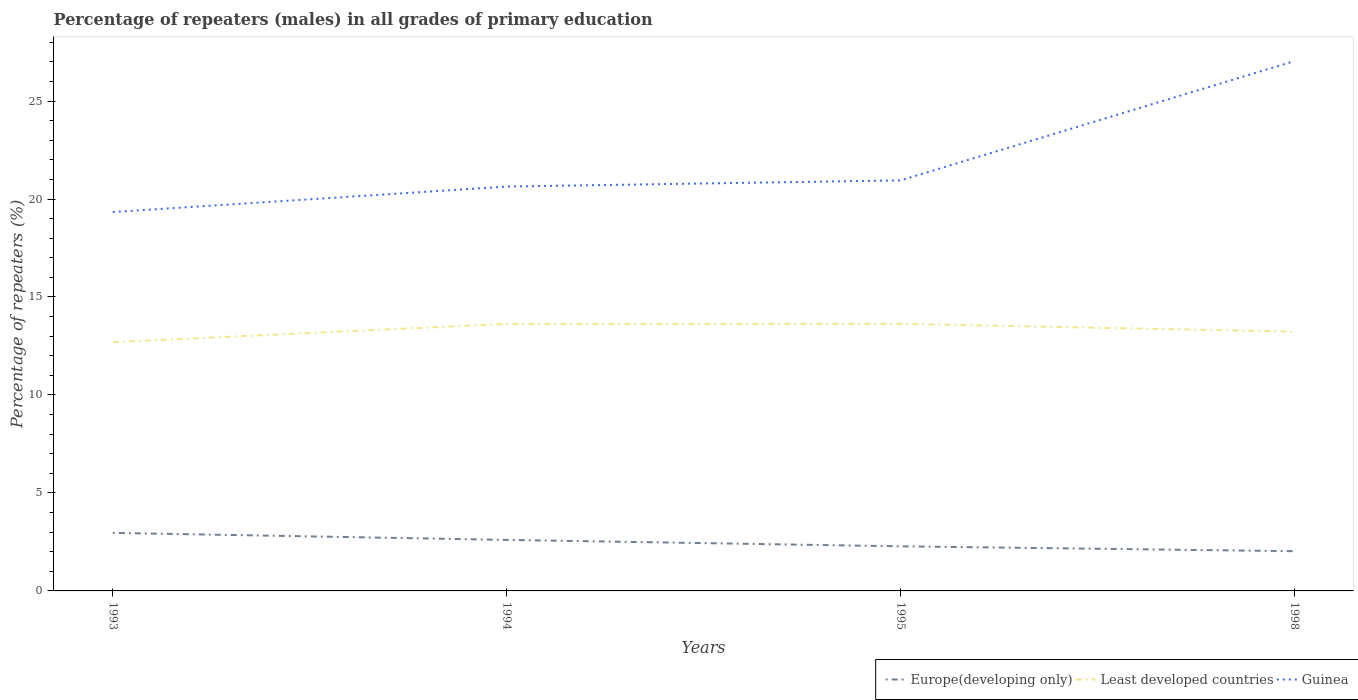How many different coloured lines are there?
Offer a very short reply. 3. Does the line corresponding to Europe(developing only) intersect with the line corresponding to Least developed countries?
Make the answer very short. No. Across all years, what is the maximum percentage of repeaters (males) in Least developed countries?
Ensure brevity in your answer.  12.7. What is the total percentage of repeaters (males) in Guinea in the graph?
Ensure brevity in your answer.  -1.3. What is the difference between the highest and the second highest percentage of repeaters (males) in Europe(developing only)?
Your answer should be compact. 0.94. What is the difference between two consecutive major ticks on the Y-axis?
Your answer should be compact. 5. Are the values on the major ticks of Y-axis written in scientific E-notation?
Your response must be concise. No. Where does the legend appear in the graph?
Provide a succinct answer. Bottom right. How are the legend labels stacked?
Give a very brief answer. Horizontal. What is the title of the graph?
Ensure brevity in your answer.  Percentage of repeaters (males) in all grades of primary education. Does "Seychelles" appear as one of the legend labels in the graph?
Offer a very short reply. No. What is the label or title of the X-axis?
Give a very brief answer. Years. What is the label or title of the Y-axis?
Keep it short and to the point. Percentage of repeaters (%). What is the Percentage of repeaters (%) in Europe(developing only) in 1993?
Offer a terse response. 2.96. What is the Percentage of repeaters (%) of Least developed countries in 1993?
Your answer should be compact. 12.7. What is the Percentage of repeaters (%) in Guinea in 1993?
Offer a terse response. 19.34. What is the Percentage of repeaters (%) of Europe(developing only) in 1994?
Make the answer very short. 2.6. What is the Percentage of repeaters (%) of Least developed countries in 1994?
Keep it short and to the point. 13.63. What is the Percentage of repeaters (%) in Guinea in 1994?
Offer a very short reply. 20.64. What is the Percentage of repeaters (%) in Europe(developing only) in 1995?
Offer a terse response. 2.28. What is the Percentage of repeaters (%) in Least developed countries in 1995?
Give a very brief answer. 13.63. What is the Percentage of repeaters (%) in Guinea in 1995?
Ensure brevity in your answer.  20.95. What is the Percentage of repeaters (%) in Europe(developing only) in 1998?
Your answer should be very brief. 2.03. What is the Percentage of repeaters (%) of Least developed countries in 1998?
Provide a succinct answer. 13.23. What is the Percentage of repeaters (%) in Guinea in 1998?
Your response must be concise. 27.04. Across all years, what is the maximum Percentage of repeaters (%) of Europe(developing only)?
Offer a very short reply. 2.96. Across all years, what is the maximum Percentage of repeaters (%) in Least developed countries?
Make the answer very short. 13.63. Across all years, what is the maximum Percentage of repeaters (%) in Guinea?
Make the answer very short. 27.04. Across all years, what is the minimum Percentage of repeaters (%) of Europe(developing only)?
Your response must be concise. 2.03. Across all years, what is the minimum Percentage of repeaters (%) in Least developed countries?
Your response must be concise. 12.7. Across all years, what is the minimum Percentage of repeaters (%) in Guinea?
Make the answer very short. 19.34. What is the total Percentage of repeaters (%) of Europe(developing only) in the graph?
Keep it short and to the point. 9.87. What is the total Percentage of repeaters (%) of Least developed countries in the graph?
Provide a short and direct response. 53.19. What is the total Percentage of repeaters (%) of Guinea in the graph?
Your answer should be compact. 87.96. What is the difference between the Percentage of repeaters (%) of Europe(developing only) in 1993 and that in 1994?
Your response must be concise. 0.36. What is the difference between the Percentage of repeaters (%) of Least developed countries in 1993 and that in 1994?
Give a very brief answer. -0.93. What is the difference between the Percentage of repeaters (%) of Guinea in 1993 and that in 1994?
Give a very brief answer. -1.3. What is the difference between the Percentage of repeaters (%) in Europe(developing only) in 1993 and that in 1995?
Give a very brief answer. 0.69. What is the difference between the Percentage of repeaters (%) in Least developed countries in 1993 and that in 1995?
Your answer should be compact. -0.93. What is the difference between the Percentage of repeaters (%) of Guinea in 1993 and that in 1995?
Give a very brief answer. -1.61. What is the difference between the Percentage of repeaters (%) in Europe(developing only) in 1993 and that in 1998?
Give a very brief answer. 0.94. What is the difference between the Percentage of repeaters (%) in Least developed countries in 1993 and that in 1998?
Provide a succinct answer. -0.54. What is the difference between the Percentage of repeaters (%) in Guinea in 1993 and that in 1998?
Keep it short and to the point. -7.7. What is the difference between the Percentage of repeaters (%) of Europe(developing only) in 1994 and that in 1995?
Your response must be concise. 0.33. What is the difference between the Percentage of repeaters (%) of Least developed countries in 1994 and that in 1995?
Provide a succinct answer. -0. What is the difference between the Percentage of repeaters (%) in Guinea in 1994 and that in 1995?
Offer a terse response. -0.31. What is the difference between the Percentage of repeaters (%) of Europe(developing only) in 1994 and that in 1998?
Your answer should be very brief. 0.58. What is the difference between the Percentage of repeaters (%) in Least developed countries in 1994 and that in 1998?
Give a very brief answer. 0.4. What is the difference between the Percentage of repeaters (%) of Guinea in 1994 and that in 1998?
Give a very brief answer. -6.4. What is the difference between the Percentage of repeaters (%) in Europe(developing only) in 1995 and that in 1998?
Keep it short and to the point. 0.25. What is the difference between the Percentage of repeaters (%) of Least developed countries in 1995 and that in 1998?
Your answer should be very brief. 0.4. What is the difference between the Percentage of repeaters (%) in Guinea in 1995 and that in 1998?
Make the answer very short. -6.09. What is the difference between the Percentage of repeaters (%) in Europe(developing only) in 1993 and the Percentage of repeaters (%) in Least developed countries in 1994?
Your response must be concise. -10.67. What is the difference between the Percentage of repeaters (%) of Europe(developing only) in 1993 and the Percentage of repeaters (%) of Guinea in 1994?
Offer a very short reply. -17.67. What is the difference between the Percentage of repeaters (%) of Least developed countries in 1993 and the Percentage of repeaters (%) of Guinea in 1994?
Your answer should be very brief. -7.94. What is the difference between the Percentage of repeaters (%) of Europe(developing only) in 1993 and the Percentage of repeaters (%) of Least developed countries in 1995?
Your response must be concise. -10.67. What is the difference between the Percentage of repeaters (%) in Europe(developing only) in 1993 and the Percentage of repeaters (%) in Guinea in 1995?
Offer a terse response. -17.99. What is the difference between the Percentage of repeaters (%) in Least developed countries in 1993 and the Percentage of repeaters (%) in Guinea in 1995?
Provide a short and direct response. -8.25. What is the difference between the Percentage of repeaters (%) of Europe(developing only) in 1993 and the Percentage of repeaters (%) of Least developed countries in 1998?
Your response must be concise. -10.27. What is the difference between the Percentage of repeaters (%) in Europe(developing only) in 1993 and the Percentage of repeaters (%) in Guinea in 1998?
Provide a short and direct response. -24.08. What is the difference between the Percentage of repeaters (%) in Least developed countries in 1993 and the Percentage of repeaters (%) in Guinea in 1998?
Your answer should be compact. -14.34. What is the difference between the Percentage of repeaters (%) in Europe(developing only) in 1994 and the Percentage of repeaters (%) in Least developed countries in 1995?
Your response must be concise. -11.03. What is the difference between the Percentage of repeaters (%) in Europe(developing only) in 1994 and the Percentage of repeaters (%) in Guinea in 1995?
Keep it short and to the point. -18.35. What is the difference between the Percentage of repeaters (%) of Least developed countries in 1994 and the Percentage of repeaters (%) of Guinea in 1995?
Make the answer very short. -7.32. What is the difference between the Percentage of repeaters (%) of Europe(developing only) in 1994 and the Percentage of repeaters (%) of Least developed countries in 1998?
Your answer should be compact. -10.63. What is the difference between the Percentage of repeaters (%) in Europe(developing only) in 1994 and the Percentage of repeaters (%) in Guinea in 1998?
Offer a very short reply. -24.44. What is the difference between the Percentage of repeaters (%) of Least developed countries in 1994 and the Percentage of repeaters (%) of Guinea in 1998?
Offer a terse response. -13.41. What is the difference between the Percentage of repeaters (%) of Europe(developing only) in 1995 and the Percentage of repeaters (%) of Least developed countries in 1998?
Make the answer very short. -10.96. What is the difference between the Percentage of repeaters (%) in Europe(developing only) in 1995 and the Percentage of repeaters (%) in Guinea in 1998?
Offer a very short reply. -24.76. What is the difference between the Percentage of repeaters (%) in Least developed countries in 1995 and the Percentage of repeaters (%) in Guinea in 1998?
Your answer should be very brief. -13.41. What is the average Percentage of repeaters (%) in Europe(developing only) per year?
Keep it short and to the point. 2.47. What is the average Percentage of repeaters (%) of Least developed countries per year?
Provide a short and direct response. 13.3. What is the average Percentage of repeaters (%) in Guinea per year?
Your response must be concise. 21.99. In the year 1993, what is the difference between the Percentage of repeaters (%) in Europe(developing only) and Percentage of repeaters (%) in Least developed countries?
Keep it short and to the point. -9.73. In the year 1993, what is the difference between the Percentage of repeaters (%) in Europe(developing only) and Percentage of repeaters (%) in Guinea?
Ensure brevity in your answer.  -16.37. In the year 1993, what is the difference between the Percentage of repeaters (%) in Least developed countries and Percentage of repeaters (%) in Guinea?
Offer a terse response. -6.64. In the year 1994, what is the difference between the Percentage of repeaters (%) in Europe(developing only) and Percentage of repeaters (%) in Least developed countries?
Ensure brevity in your answer.  -11.02. In the year 1994, what is the difference between the Percentage of repeaters (%) in Europe(developing only) and Percentage of repeaters (%) in Guinea?
Make the answer very short. -18.03. In the year 1994, what is the difference between the Percentage of repeaters (%) of Least developed countries and Percentage of repeaters (%) of Guinea?
Offer a very short reply. -7.01. In the year 1995, what is the difference between the Percentage of repeaters (%) of Europe(developing only) and Percentage of repeaters (%) of Least developed countries?
Make the answer very short. -11.35. In the year 1995, what is the difference between the Percentage of repeaters (%) of Europe(developing only) and Percentage of repeaters (%) of Guinea?
Your answer should be very brief. -18.67. In the year 1995, what is the difference between the Percentage of repeaters (%) of Least developed countries and Percentage of repeaters (%) of Guinea?
Make the answer very short. -7.32. In the year 1998, what is the difference between the Percentage of repeaters (%) of Europe(developing only) and Percentage of repeaters (%) of Least developed countries?
Your answer should be compact. -11.21. In the year 1998, what is the difference between the Percentage of repeaters (%) of Europe(developing only) and Percentage of repeaters (%) of Guinea?
Your answer should be compact. -25.01. In the year 1998, what is the difference between the Percentage of repeaters (%) in Least developed countries and Percentage of repeaters (%) in Guinea?
Your answer should be compact. -13.81. What is the ratio of the Percentage of repeaters (%) in Europe(developing only) in 1993 to that in 1994?
Provide a succinct answer. 1.14. What is the ratio of the Percentage of repeaters (%) of Least developed countries in 1993 to that in 1994?
Make the answer very short. 0.93. What is the ratio of the Percentage of repeaters (%) of Guinea in 1993 to that in 1994?
Your answer should be compact. 0.94. What is the ratio of the Percentage of repeaters (%) in Europe(developing only) in 1993 to that in 1995?
Keep it short and to the point. 1.3. What is the ratio of the Percentage of repeaters (%) in Least developed countries in 1993 to that in 1995?
Give a very brief answer. 0.93. What is the ratio of the Percentage of repeaters (%) in Guinea in 1993 to that in 1995?
Your response must be concise. 0.92. What is the ratio of the Percentage of repeaters (%) of Europe(developing only) in 1993 to that in 1998?
Offer a very short reply. 1.46. What is the ratio of the Percentage of repeaters (%) in Least developed countries in 1993 to that in 1998?
Offer a very short reply. 0.96. What is the ratio of the Percentage of repeaters (%) in Guinea in 1993 to that in 1998?
Make the answer very short. 0.72. What is the ratio of the Percentage of repeaters (%) of Europe(developing only) in 1994 to that in 1995?
Make the answer very short. 1.14. What is the ratio of the Percentage of repeaters (%) in Least developed countries in 1994 to that in 1995?
Offer a terse response. 1. What is the ratio of the Percentage of repeaters (%) of Guinea in 1994 to that in 1995?
Your answer should be very brief. 0.98. What is the ratio of the Percentage of repeaters (%) of Europe(developing only) in 1994 to that in 1998?
Provide a succinct answer. 1.28. What is the ratio of the Percentage of repeaters (%) in Least developed countries in 1994 to that in 1998?
Your answer should be compact. 1.03. What is the ratio of the Percentage of repeaters (%) of Guinea in 1994 to that in 1998?
Keep it short and to the point. 0.76. What is the ratio of the Percentage of repeaters (%) in Europe(developing only) in 1995 to that in 1998?
Offer a very short reply. 1.12. What is the ratio of the Percentage of repeaters (%) in Least developed countries in 1995 to that in 1998?
Your answer should be compact. 1.03. What is the ratio of the Percentage of repeaters (%) of Guinea in 1995 to that in 1998?
Give a very brief answer. 0.77. What is the difference between the highest and the second highest Percentage of repeaters (%) of Europe(developing only)?
Ensure brevity in your answer.  0.36. What is the difference between the highest and the second highest Percentage of repeaters (%) of Least developed countries?
Ensure brevity in your answer.  0. What is the difference between the highest and the second highest Percentage of repeaters (%) of Guinea?
Keep it short and to the point. 6.09. What is the difference between the highest and the lowest Percentage of repeaters (%) in Europe(developing only)?
Provide a short and direct response. 0.94. What is the difference between the highest and the lowest Percentage of repeaters (%) of Least developed countries?
Make the answer very short. 0.93. What is the difference between the highest and the lowest Percentage of repeaters (%) of Guinea?
Give a very brief answer. 7.7. 